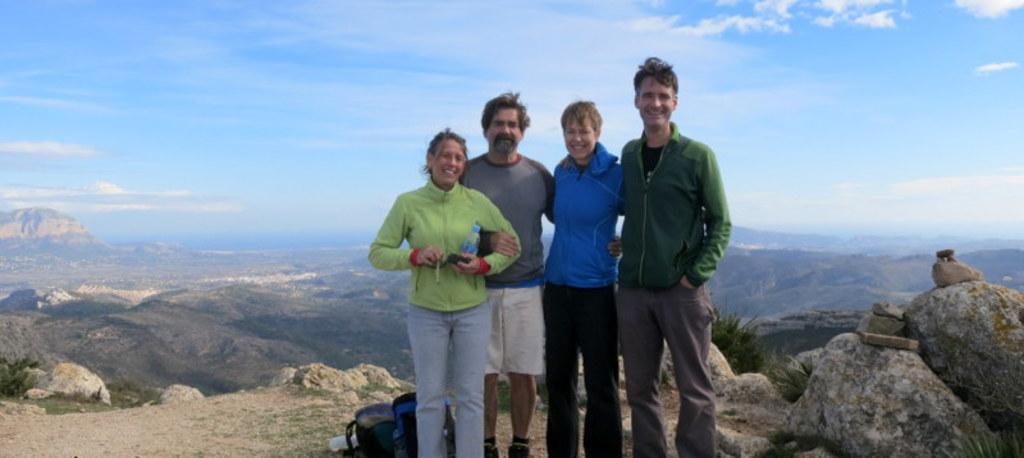In one or two sentences, can you explain what this image depicts? In the picture we can see two men and two women standing together and posing for a photograph and in the background of the picture there are some mountains and top of the picture there is clear sky. 